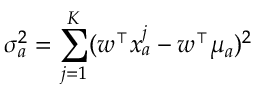Convert formula to latex. <formula><loc_0><loc_0><loc_500><loc_500>\sigma _ { a } ^ { 2 } = \sum _ { j = 1 } ^ { K } ( w ^ { \intercal } x _ { a } ^ { j } - w ^ { \intercal } \mu _ { a } ) ^ { 2 }</formula> 